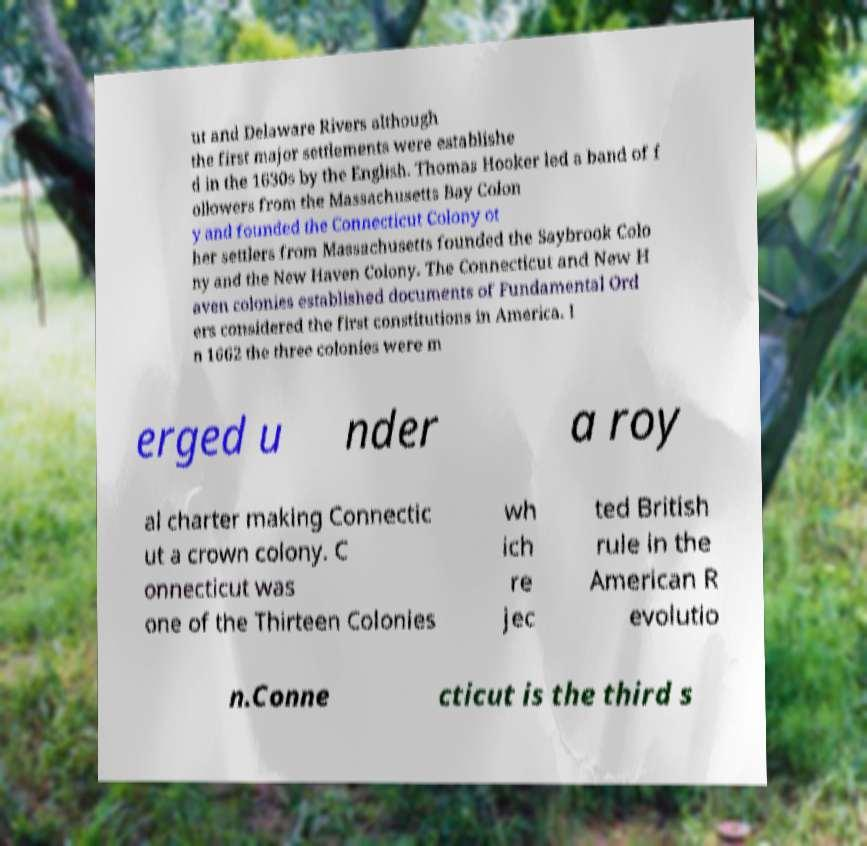Please read and relay the text visible in this image. What does it say? ut and Delaware Rivers although the first major settlements were establishe d in the 1630s by the English. Thomas Hooker led a band of f ollowers from the Massachusetts Bay Colon y and founded the Connecticut Colony ot her settlers from Massachusetts founded the Saybrook Colo ny and the New Haven Colony. The Connecticut and New H aven colonies established documents of Fundamental Ord ers considered the first constitutions in America. I n 1662 the three colonies were m erged u nder a roy al charter making Connectic ut a crown colony. C onnecticut was one of the Thirteen Colonies wh ich re jec ted British rule in the American R evolutio n.Conne cticut is the third s 